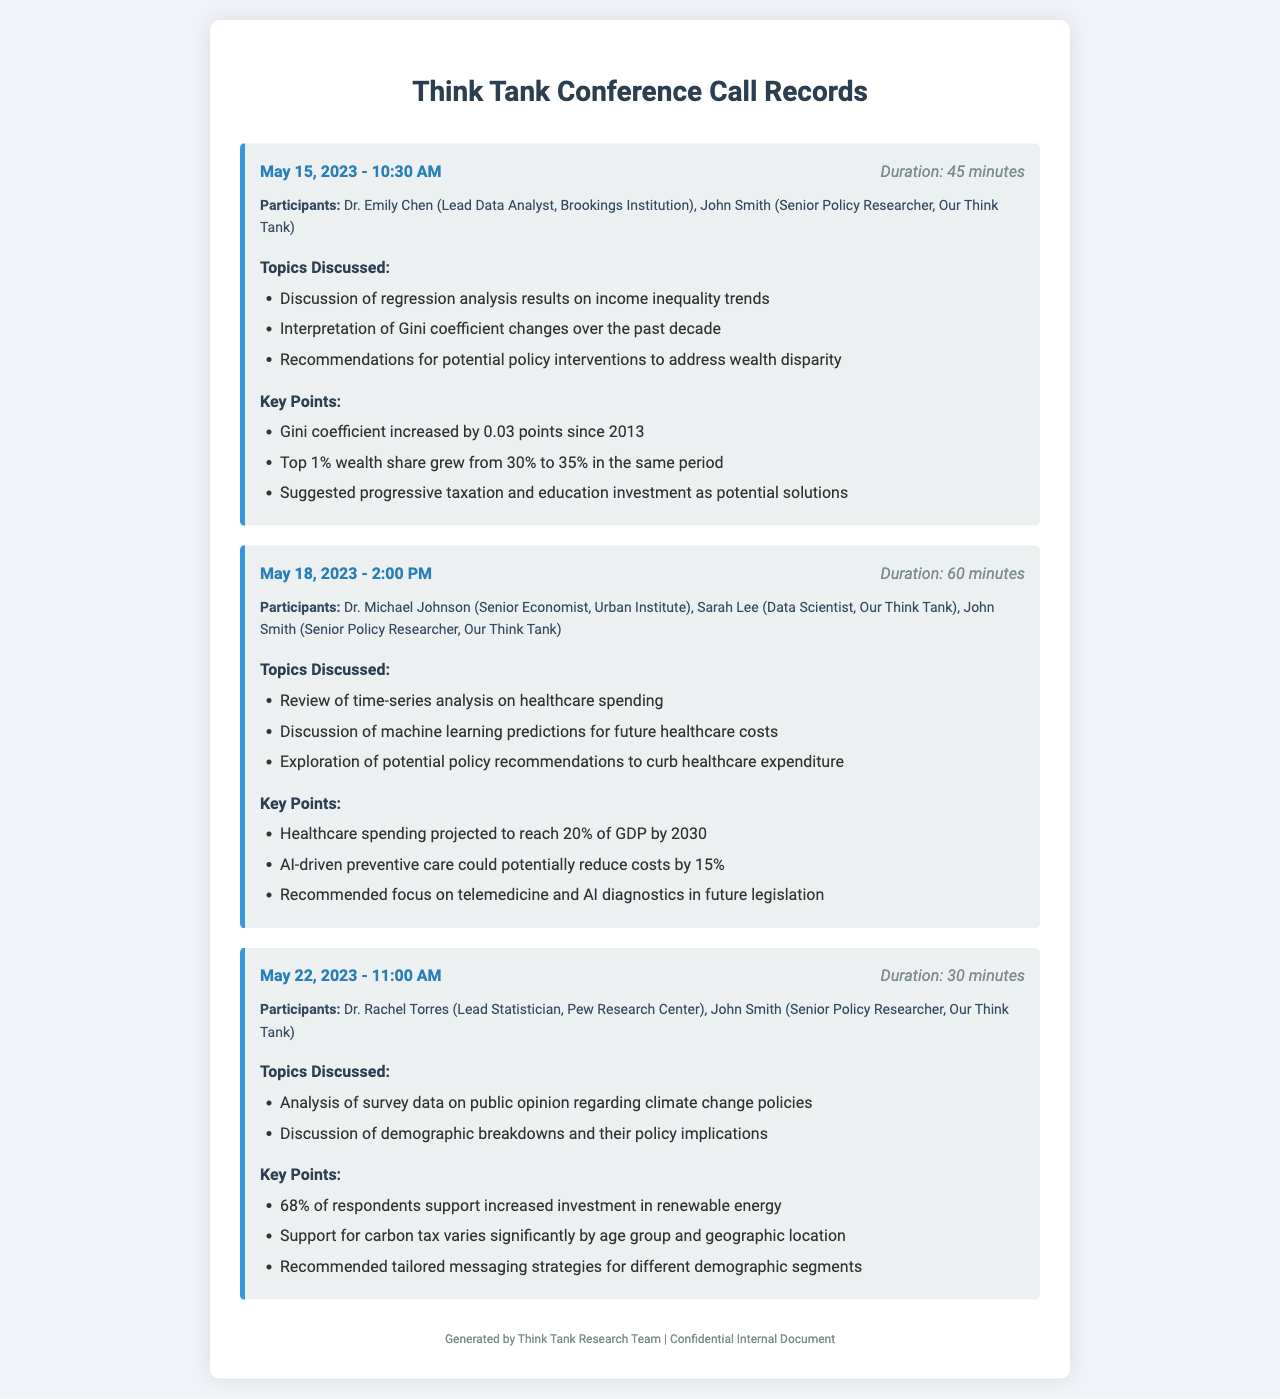what is the date of the first conference call? The first conference call recorded took place on May 15, 2023.
Answer: May 15, 2023 who participated in the second conference call? The participants in the second call were Dr. Michael Johnson, Sarah Lee, and John Smith.
Answer: Dr. Michael Johnson, Sarah Lee, John Smith what topic was discussed on May 22, 2023? The topic discussed on this date was the analysis of survey data on public opinion regarding climate change policies.
Answer: analysis of survey data on public opinion regarding climate change policies how long did the first conference call last? The duration of the first conference call was 45 minutes.
Answer: 45 minutes what recommendation was suggested regarding healthcare costs? The recommendation suggested for addressing healthcare costs was to focus on telemedicine and AI diagnostics.
Answer: focus on telemedicine and AI diagnostics what was the Gini coefficient increase since 2013? The Gini coefficient increased by 0.03 points since 2013.
Answer: 0.03 points which demographic showed significant support for renewable energy investment? The document indicates that 68% of respondents support increased investment in renewable energy.
Answer: 68% what is projected healthcare spending by 2030? Healthcare spending is projected to reach 20% of GDP by 2030.
Answer: 20% of GDP what was the shared wealth increase of the top 1% from 2013? The top 1% wealth share grew from 30% to 35% in the same period.
Answer: from 30% to 35% 